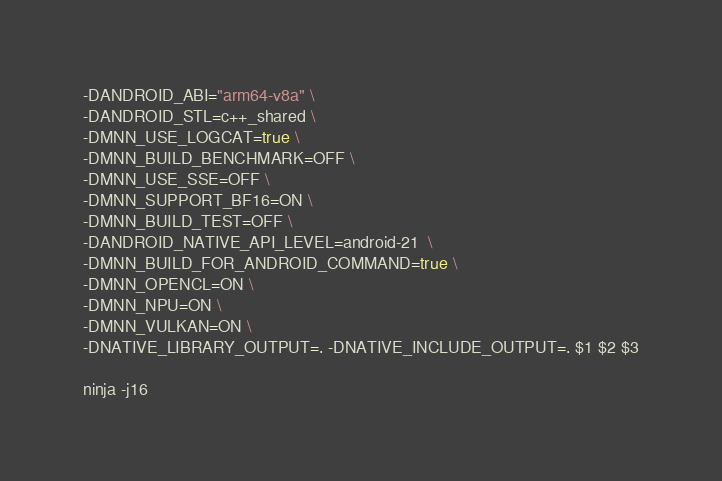Convert code to text. <code><loc_0><loc_0><loc_500><loc_500><_Bash_>-DANDROID_ABI="arm64-v8a" \
-DANDROID_STL=c++_shared \
-DMNN_USE_LOGCAT=true \
-DMNN_BUILD_BENCHMARK=OFF \
-DMNN_USE_SSE=OFF \
-DMNN_SUPPORT_BF16=ON \
-DMNN_BUILD_TEST=OFF \
-DANDROID_NATIVE_API_LEVEL=android-21  \
-DMNN_BUILD_FOR_ANDROID_COMMAND=true \
-DMNN_OPENCL=ON \
-DMNN_NPU=ON \
-DMNN_VULKAN=ON \
-DNATIVE_LIBRARY_OUTPUT=. -DNATIVE_INCLUDE_OUTPUT=. $1 $2 $3

ninja -j16
</code> 